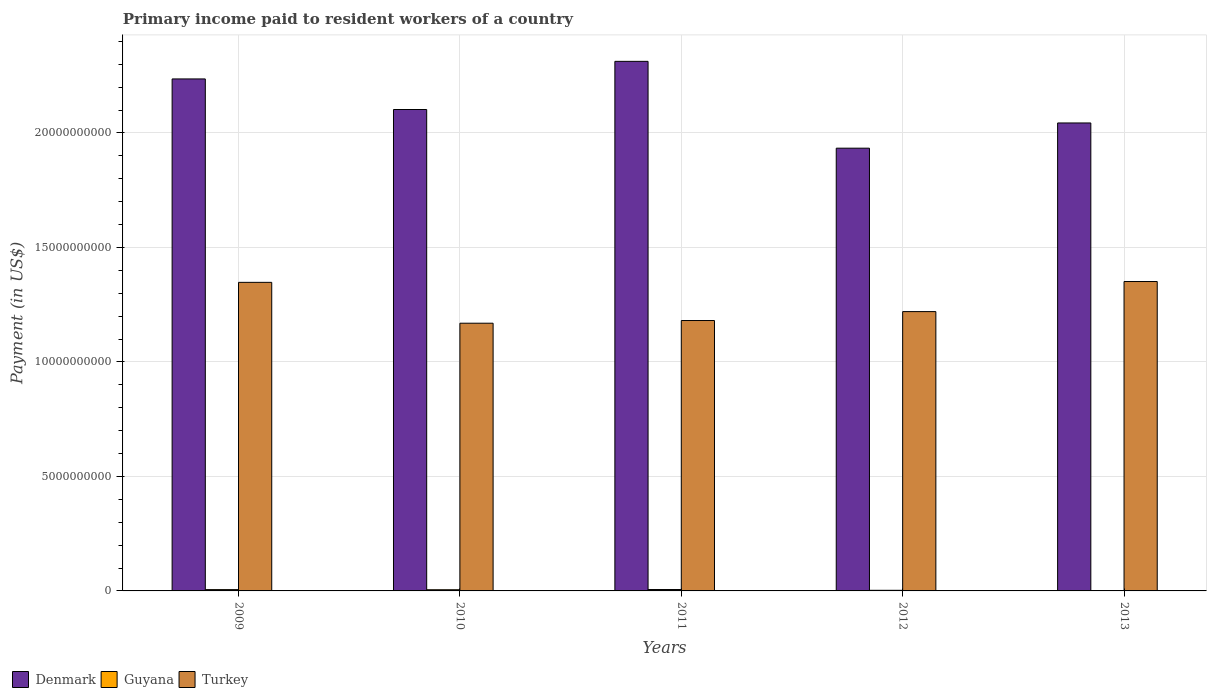How many different coloured bars are there?
Give a very brief answer. 3. How many groups of bars are there?
Provide a succinct answer. 5. Are the number of bars on each tick of the X-axis equal?
Your answer should be compact. Yes. How many bars are there on the 3rd tick from the right?
Offer a terse response. 3. In how many cases, is the number of bars for a given year not equal to the number of legend labels?
Your response must be concise. 0. What is the amount paid to workers in Guyana in 2011?
Offer a terse response. 6.12e+07. Across all years, what is the maximum amount paid to workers in Turkey?
Ensure brevity in your answer.  1.35e+1. Across all years, what is the minimum amount paid to workers in Turkey?
Your answer should be compact. 1.17e+1. In which year was the amount paid to workers in Denmark minimum?
Offer a very short reply. 2012. What is the total amount paid to workers in Denmark in the graph?
Provide a short and direct response. 1.06e+11. What is the difference between the amount paid to workers in Guyana in 2009 and that in 2010?
Ensure brevity in your answer.  5.47e+06. What is the difference between the amount paid to workers in Turkey in 2011 and the amount paid to workers in Guyana in 2013?
Your response must be concise. 1.18e+1. What is the average amount paid to workers in Guyana per year?
Your answer should be very brief. 4.24e+07. In the year 2010, what is the difference between the amount paid to workers in Guyana and amount paid to workers in Turkey?
Keep it short and to the point. -1.16e+1. In how many years, is the amount paid to workers in Denmark greater than 12000000000 US$?
Your answer should be compact. 5. What is the ratio of the amount paid to workers in Denmark in 2011 to that in 2013?
Ensure brevity in your answer.  1.13. Is the difference between the amount paid to workers in Guyana in 2010 and 2012 greater than the difference between the amount paid to workers in Turkey in 2010 and 2012?
Give a very brief answer. Yes. What is the difference between the highest and the second highest amount paid to workers in Denmark?
Your response must be concise. 7.68e+08. What is the difference between the highest and the lowest amount paid to workers in Turkey?
Your answer should be very brief. 1.82e+09. What does the 1st bar from the right in 2009 represents?
Provide a short and direct response. Turkey. Is it the case that in every year, the sum of the amount paid to workers in Guyana and amount paid to workers in Denmark is greater than the amount paid to workers in Turkey?
Your answer should be very brief. Yes. How many bars are there?
Offer a terse response. 15. Are all the bars in the graph horizontal?
Your answer should be compact. No. Does the graph contain any zero values?
Give a very brief answer. No. How are the legend labels stacked?
Make the answer very short. Horizontal. What is the title of the graph?
Ensure brevity in your answer.  Primary income paid to resident workers of a country. Does "Cuba" appear as one of the legend labels in the graph?
Your response must be concise. No. What is the label or title of the Y-axis?
Your answer should be very brief. Payment (in US$). What is the Payment (in US$) in Denmark in 2009?
Make the answer very short. 2.24e+1. What is the Payment (in US$) of Guyana in 2009?
Your answer should be compact. 5.67e+07. What is the Payment (in US$) in Turkey in 2009?
Offer a very short reply. 1.35e+1. What is the Payment (in US$) of Denmark in 2010?
Provide a succinct answer. 2.10e+1. What is the Payment (in US$) of Guyana in 2010?
Ensure brevity in your answer.  5.12e+07. What is the Payment (in US$) in Turkey in 2010?
Your answer should be compact. 1.17e+1. What is the Payment (in US$) of Denmark in 2011?
Make the answer very short. 2.31e+1. What is the Payment (in US$) of Guyana in 2011?
Make the answer very short. 6.12e+07. What is the Payment (in US$) of Turkey in 2011?
Your answer should be compact. 1.18e+1. What is the Payment (in US$) in Denmark in 2012?
Make the answer very short. 1.93e+1. What is the Payment (in US$) in Guyana in 2012?
Offer a very short reply. 2.69e+07. What is the Payment (in US$) in Turkey in 2012?
Make the answer very short. 1.22e+1. What is the Payment (in US$) in Denmark in 2013?
Make the answer very short. 2.04e+1. What is the Payment (in US$) in Guyana in 2013?
Offer a very short reply. 1.60e+07. What is the Payment (in US$) of Turkey in 2013?
Offer a terse response. 1.35e+1. Across all years, what is the maximum Payment (in US$) of Denmark?
Your answer should be very brief. 2.31e+1. Across all years, what is the maximum Payment (in US$) of Guyana?
Your answer should be very brief. 6.12e+07. Across all years, what is the maximum Payment (in US$) in Turkey?
Your response must be concise. 1.35e+1. Across all years, what is the minimum Payment (in US$) of Denmark?
Offer a terse response. 1.93e+1. Across all years, what is the minimum Payment (in US$) of Guyana?
Provide a short and direct response. 1.60e+07. Across all years, what is the minimum Payment (in US$) of Turkey?
Your answer should be compact. 1.17e+1. What is the total Payment (in US$) of Denmark in the graph?
Make the answer very short. 1.06e+11. What is the total Payment (in US$) in Guyana in the graph?
Give a very brief answer. 2.12e+08. What is the total Payment (in US$) of Turkey in the graph?
Your answer should be very brief. 6.27e+1. What is the difference between the Payment (in US$) of Denmark in 2009 and that in 2010?
Make the answer very short. 1.33e+09. What is the difference between the Payment (in US$) in Guyana in 2009 and that in 2010?
Your answer should be very brief. 5.47e+06. What is the difference between the Payment (in US$) of Turkey in 2009 and that in 2010?
Make the answer very short. 1.78e+09. What is the difference between the Payment (in US$) in Denmark in 2009 and that in 2011?
Offer a terse response. -7.68e+08. What is the difference between the Payment (in US$) of Guyana in 2009 and that in 2011?
Keep it short and to the point. -4.54e+06. What is the difference between the Payment (in US$) in Turkey in 2009 and that in 2011?
Your answer should be very brief. 1.67e+09. What is the difference between the Payment (in US$) in Denmark in 2009 and that in 2012?
Your answer should be compact. 3.02e+09. What is the difference between the Payment (in US$) of Guyana in 2009 and that in 2012?
Give a very brief answer. 2.98e+07. What is the difference between the Payment (in US$) in Turkey in 2009 and that in 2012?
Your answer should be very brief. 1.28e+09. What is the difference between the Payment (in US$) in Denmark in 2009 and that in 2013?
Make the answer very short. 1.92e+09. What is the difference between the Payment (in US$) of Guyana in 2009 and that in 2013?
Provide a short and direct response. 4.07e+07. What is the difference between the Payment (in US$) of Turkey in 2009 and that in 2013?
Your response must be concise. -3.60e+07. What is the difference between the Payment (in US$) of Denmark in 2010 and that in 2011?
Keep it short and to the point. -2.10e+09. What is the difference between the Payment (in US$) of Guyana in 2010 and that in 2011?
Keep it short and to the point. -1.00e+07. What is the difference between the Payment (in US$) in Turkey in 2010 and that in 2011?
Provide a short and direct response. -1.17e+08. What is the difference between the Payment (in US$) in Denmark in 2010 and that in 2012?
Give a very brief answer. 1.69e+09. What is the difference between the Payment (in US$) in Guyana in 2010 and that in 2012?
Give a very brief answer. 2.44e+07. What is the difference between the Payment (in US$) in Turkey in 2010 and that in 2012?
Give a very brief answer. -5.07e+08. What is the difference between the Payment (in US$) in Denmark in 2010 and that in 2013?
Keep it short and to the point. 5.87e+08. What is the difference between the Payment (in US$) in Guyana in 2010 and that in 2013?
Make the answer very short. 3.53e+07. What is the difference between the Payment (in US$) of Turkey in 2010 and that in 2013?
Offer a very short reply. -1.82e+09. What is the difference between the Payment (in US$) in Denmark in 2011 and that in 2012?
Your answer should be compact. 3.79e+09. What is the difference between the Payment (in US$) in Guyana in 2011 and that in 2012?
Provide a short and direct response. 3.44e+07. What is the difference between the Payment (in US$) of Turkey in 2011 and that in 2012?
Offer a terse response. -3.90e+08. What is the difference between the Payment (in US$) in Denmark in 2011 and that in 2013?
Offer a terse response. 2.69e+09. What is the difference between the Payment (in US$) of Guyana in 2011 and that in 2013?
Your answer should be very brief. 4.53e+07. What is the difference between the Payment (in US$) of Turkey in 2011 and that in 2013?
Offer a terse response. -1.70e+09. What is the difference between the Payment (in US$) in Denmark in 2012 and that in 2013?
Offer a very short reply. -1.10e+09. What is the difference between the Payment (in US$) of Guyana in 2012 and that in 2013?
Your answer should be compact. 1.09e+07. What is the difference between the Payment (in US$) in Turkey in 2012 and that in 2013?
Ensure brevity in your answer.  -1.31e+09. What is the difference between the Payment (in US$) of Denmark in 2009 and the Payment (in US$) of Guyana in 2010?
Make the answer very short. 2.23e+1. What is the difference between the Payment (in US$) of Denmark in 2009 and the Payment (in US$) of Turkey in 2010?
Keep it short and to the point. 1.07e+1. What is the difference between the Payment (in US$) in Guyana in 2009 and the Payment (in US$) in Turkey in 2010?
Give a very brief answer. -1.16e+1. What is the difference between the Payment (in US$) in Denmark in 2009 and the Payment (in US$) in Guyana in 2011?
Provide a succinct answer. 2.23e+1. What is the difference between the Payment (in US$) of Denmark in 2009 and the Payment (in US$) of Turkey in 2011?
Your response must be concise. 1.05e+1. What is the difference between the Payment (in US$) of Guyana in 2009 and the Payment (in US$) of Turkey in 2011?
Your response must be concise. -1.18e+1. What is the difference between the Payment (in US$) of Denmark in 2009 and the Payment (in US$) of Guyana in 2012?
Ensure brevity in your answer.  2.23e+1. What is the difference between the Payment (in US$) of Denmark in 2009 and the Payment (in US$) of Turkey in 2012?
Provide a succinct answer. 1.02e+1. What is the difference between the Payment (in US$) in Guyana in 2009 and the Payment (in US$) in Turkey in 2012?
Your answer should be compact. -1.21e+1. What is the difference between the Payment (in US$) in Denmark in 2009 and the Payment (in US$) in Guyana in 2013?
Your answer should be compact. 2.23e+1. What is the difference between the Payment (in US$) of Denmark in 2009 and the Payment (in US$) of Turkey in 2013?
Your response must be concise. 8.85e+09. What is the difference between the Payment (in US$) in Guyana in 2009 and the Payment (in US$) in Turkey in 2013?
Provide a short and direct response. -1.35e+1. What is the difference between the Payment (in US$) in Denmark in 2010 and the Payment (in US$) in Guyana in 2011?
Make the answer very short. 2.10e+1. What is the difference between the Payment (in US$) of Denmark in 2010 and the Payment (in US$) of Turkey in 2011?
Ensure brevity in your answer.  9.21e+09. What is the difference between the Payment (in US$) in Guyana in 2010 and the Payment (in US$) in Turkey in 2011?
Offer a very short reply. -1.18e+1. What is the difference between the Payment (in US$) in Denmark in 2010 and the Payment (in US$) in Guyana in 2012?
Provide a short and direct response. 2.10e+1. What is the difference between the Payment (in US$) of Denmark in 2010 and the Payment (in US$) of Turkey in 2012?
Offer a terse response. 8.82e+09. What is the difference between the Payment (in US$) of Guyana in 2010 and the Payment (in US$) of Turkey in 2012?
Provide a short and direct response. -1.21e+1. What is the difference between the Payment (in US$) of Denmark in 2010 and the Payment (in US$) of Guyana in 2013?
Give a very brief answer. 2.10e+1. What is the difference between the Payment (in US$) in Denmark in 2010 and the Payment (in US$) in Turkey in 2013?
Provide a short and direct response. 7.51e+09. What is the difference between the Payment (in US$) in Guyana in 2010 and the Payment (in US$) in Turkey in 2013?
Offer a very short reply. -1.35e+1. What is the difference between the Payment (in US$) of Denmark in 2011 and the Payment (in US$) of Guyana in 2012?
Keep it short and to the point. 2.31e+1. What is the difference between the Payment (in US$) of Denmark in 2011 and the Payment (in US$) of Turkey in 2012?
Offer a very short reply. 1.09e+1. What is the difference between the Payment (in US$) of Guyana in 2011 and the Payment (in US$) of Turkey in 2012?
Offer a terse response. -1.21e+1. What is the difference between the Payment (in US$) in Denmark in 2011 and the Payment (in US$) in Guyana in 2013?
Your response must be concise. 2.31e+1. What is the difference between the Payment (in US$) of Denmark in 2011 and the Payment (in US$) of Turkey in 2013?
Your answer should be compact. 9.61e+09. What is the difference between the Payment (in US$) in Guyana in 2011 and the Payment (in US$) in Turkey in 2013?
Make the answer very short. -1.34e+1. What is the difference between the Payment (in US$) in Denmark in 2012 and the Payment (in US$) in Guyana in 2013?
Give a very brief answer. 1.93e+1. What is the difference between the Payment (in US$) of Denmark in 2012 and the Payment (in US$) of Turkey in 2013?
Provide a succinct answer. 5.82e+09. What is the difference between the Payment (in US$) in Guyana in 2012 and the Payment (in US$) in Turkey in 2013?
Give a very brief answer. -1.35e+1. What is the average Payment (in US$) in Denmark per year?
Make the answer very short. 2.13e+1. What is the average Payment (in US$) in Guyana per year?
Your answer should be compact. 4.24e+07. What is the average Payment (in US$) of Turkey per year?
Offer a very short reply. 1.25e+1. In the year 2009, what is the difference between the Payment (in US$) of Denmark and Payment (in US$) of Guyana?
Your answer should be very brief. 2.23e+1. In the year 2009, what is the difference between the Payment (in US$) of Denmark and Payment (in US$) of Turkey?
Provide a succinct answer. 8.88e+09. In the year 2009, what is the difference between the Payment (in US$) in Guyana and Payment (in US$) in Turkey?
Make the answer very short. -1.34e+1. In the year 2010, what is the difference between the Payment (in US$) of Denmark and Payment (in US$) of Guyana?
Offer a very short reply. 2.10e+1. In the year 2010, what is the difference between the Payment (in US$) of Denmark and Payment (in US$) of Turkey?
Ensure brevity in your answer.  9.33e+09. In the year 2010, what is the difference between the Payment (in US$) in Guyana and Payment (in US$) in Turkey?
Offer a terse response. -1.16e+1. In the year 2011, what is the difference between the Payment (in US$) of Denmark and Payment (in US$) of Guyana?
Ensure brevity in your answer.  2.31e+1. In the year 2011, what is the difference between the Payment (in US$) of Denmark and Payment (in US$) of Turkey?
Make the answer very short. 1.13e+1. In the year 2011, what is the difference between the Payment (in US$) in Guyana and Payment (in US$) in Turkey?
Make the answer very short. -1.17e+1. In the year 2012, what is the difference between the Payment (in US$) in Denmark and Payment (in US$) in Guyana?
Offer a very short reply. 1.93e+1. In the year 2012, what is the difference between the Payment (in US$) of Denmark and Payment (in US$) of Turkey?
Ensure brevity in your answer.  7.14e+09. In the year 2012, what is the difference between the Payment (in US$) in Guyana and Payment (in US$) in Turkey?
Keep it short and to the point. -1.22e+1. In the year 2013, what is the difference between the Payment (in US$) of Denmark and Payment (in US$) of Guyana?
Ensure brevity in your answer.  2.04e+1. In the year 2013, what is the difference between the Payment (in US$) of Denmark and Payment (in US$) of Turkey?
Ensure brevity in your answer.  6.92e+09. In the year 2013, what is the difference between the Payment (in US$) in Guyana and Payment (in US$) in Turkey?
Make the answer very short. -1.35e+1. What is the ratio of the Payment (in US$) of Denmark in 2009 to that in 2010?
Provide a succinct answer. 1.06. What is the ratio of the Payment (in US$) of Guyana in 2009 to that in 2010?
Offer a very short reply. 1.11. What is the ratio of the Payment (in US$) in Turkey in 2009 to that in 2010?
Keep it short and to the point. 1.15. What is the ratio of the Payment (in US$) of Denmark in 2009 to that in 2011?
Ensure brevity in your answer.  0.97. What is the ratio of the Payment (in US$) in Guyana in 2009 to that in 2011?
Make the answer very short. 0.93. What is the ratio of the Payment (in US$) in Turkey in 2009 to that in 2011?
Ensure brevity in your answer.  1.14. What is the ratio of the Payment (in US$) in Denmark in 2009 to that in 2012?
Provide a succinct answer. 1.16. What is the ratio of the Payment (in US$) of Guyana in 2009 to that in 2012?
Keep it short and to the point. 2.11. What is the ratio of the Payment (in US$) in Turkey in 2009 to that in 2012?
Ensure brevity in your answer.  1.1. What is the ratio of the Payment (in US$) of Denmark in 2009 to that in 2013?
Your answer should be compact. 1.09. What is the ratio of the Payment (in US$) in Guyana in 2009 to that in 2013?
Give a very brief answer. 3.55. What is the ratio of the Payment (in US$) of Turkey in 2009 to that in 2013?
Provide a succinct answer. 1. What is the ratio of the Payment (in US$) of Guyana in 2010 to that in 2011?
Provide a succinct answer. 0.84. What is the ratio of the Payment (in US$) of Turkey in 2010 to that in 2011?
Your answer should be compact. 0.99. What is the ratio of the Payment (in US$) of Denmark in 2010 to that in 2012?
Keep it short and to the point. 1.09. What is the ratio of the Payment (in US$) of Guyana in 2010 to that in 2012?
Keep it short and to the point. 1.91. What is the ratio of the Payment (in US$) in Turkey in 2010 to that in 2012?
Your response must be concise. 0.96. What is the ratio of the Payment (in US$) in Denmark in 2010 to that in 2013?
Provide a succinct answer. 1.03. What is the ratio of the Payment (in US$) of Guyana in 2010 to that in 2013?
Offer a very short reply. 3.21. What is the ratio of the Payment (in US$) in Turkey in 2010 to that in 2013?
Your answer should be very brief. 0.87. What is the ratio of the Payment (in US$) in Denmark in 2011 to that in 2012?
Give a very brief answer. 1.2. What is the ratio of the Payment (in US$) of Guyana in 2011 to that in 2012?
Offer a very short reply. 2.28. What is the ratio of the Payment (in US$) in Turkey in 2011 to that in 2012?
Ensure brevity in your answer.  0.97. What is the ratio of the Payment (in US$) in Denmark in 2011 to that in 2013?
Ensure brevity in your answer.  1.13. What is the ratio of the Payment (in US$) in Guyana in 2011 to that in 2013?
Your answer should be very brief. 3.84. What is the ratio of the Payment (in US$) of Turkey in 2011 to that in 2013?
Offer a terse response. 0.87. What is the ratio of the Payment (in US$) of Denmark in 2012 to that in 2013?
Provide a succinct answer. 0.95. What is the ratio of the Payment (in US$) of Guyana in 2012 to that in 2013?
Give a very brief answer. 1.68. What is the ratio of the Payment (in US$) of Turkey in 2012 to that in 2013?
Your answer should be compact. 0.9. What is the difference between the highest and the second highest Payment (in US$) in Denmark?
Ensure brevity in your answer.  7.68e+08. What is the difference between the highest and the second highest Payment (in US$) in Guyana?
Make the answer very short. 4.54e+06. What is the difference between the highest and the second highest Payment (in US$) of Turkey?
Your answer should be very brief. 3.60e+07. What is the difference between the highest and the lowest Payment (in US$) in Denmark?
Your answer should be very brief. 3.79e+09. What is the difference between the highest and the lowest Payment (in US$) in Guyana?
Ensure brevity in your answer.  4.53e+07. What is the difference between the highest and the lowest Payment (in US$) of Turkey?
Your answer should be very brief. 1.82e+09. 